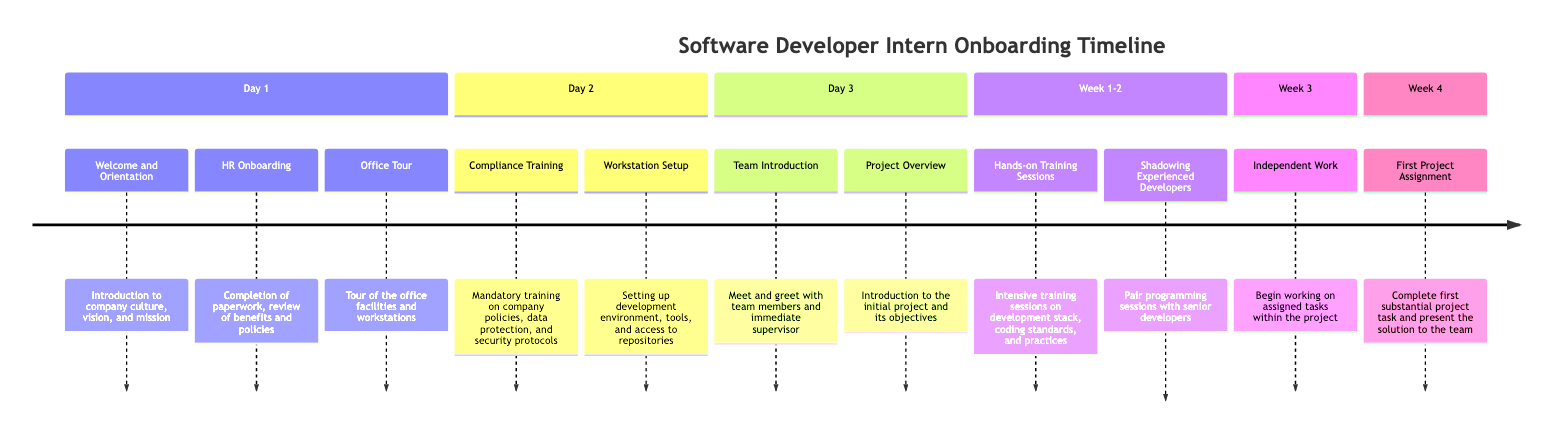What activities are scheduled for Day 1? The diagram lists three activities for Day 1: "Welcome and Orientation," "HR Onboarding," and "Office Tour."
Answer: Welcome and Orientation, HR Onboarding, Office Tour How many hours is the Compliance Training? The diagram specifies that Compliance Training lasts for 3 hours on Day 2.
Answer: 3 hours What is the duration of the Hands-on Training Sessions? According to the diagram, Hands-on Training Sessions have a duration of 3 hours per session and occur daily over Weeks 1 to 2.
Answer: 3 hours per session What happens in Week 4? The timeline indicates that in Week 4, the intern will complete their first project assignment and present the solution to the team.
Answer: First Project Assignment Which day includes the Team Introduction? The diagram shows that the Team Introduction occurs on Day 3, as listed under the Day 3 section of the timeline.
Answer: Day 3 How often do Shadowing Experienced Developers sessions take place? The timeline states that Shadowing Experienced Developers sessions are held on alternate days, implying a frequency of every other day during the Weeks 1 and 2.
Answer: Alternate days What is the main task during Week 3? During Week 3, the main task for the intern is "Independent Work," where they begin working on assigned tasks within the project.
Answer: Independent Work What support is provided during Independent Work? The diagram specifies that during Independent Work, there will be regular check-ins with mentors and team leads for support.
Answer: Regular check-ins with mentors and team leads What is the main focus of the Hands-on Training Sessions? The Hands-on Training Sessions are intensely focused on the development stack, coding standards, and development practices, as stated in the timeline.
Answer: Development stack, coding standards, and development practices 